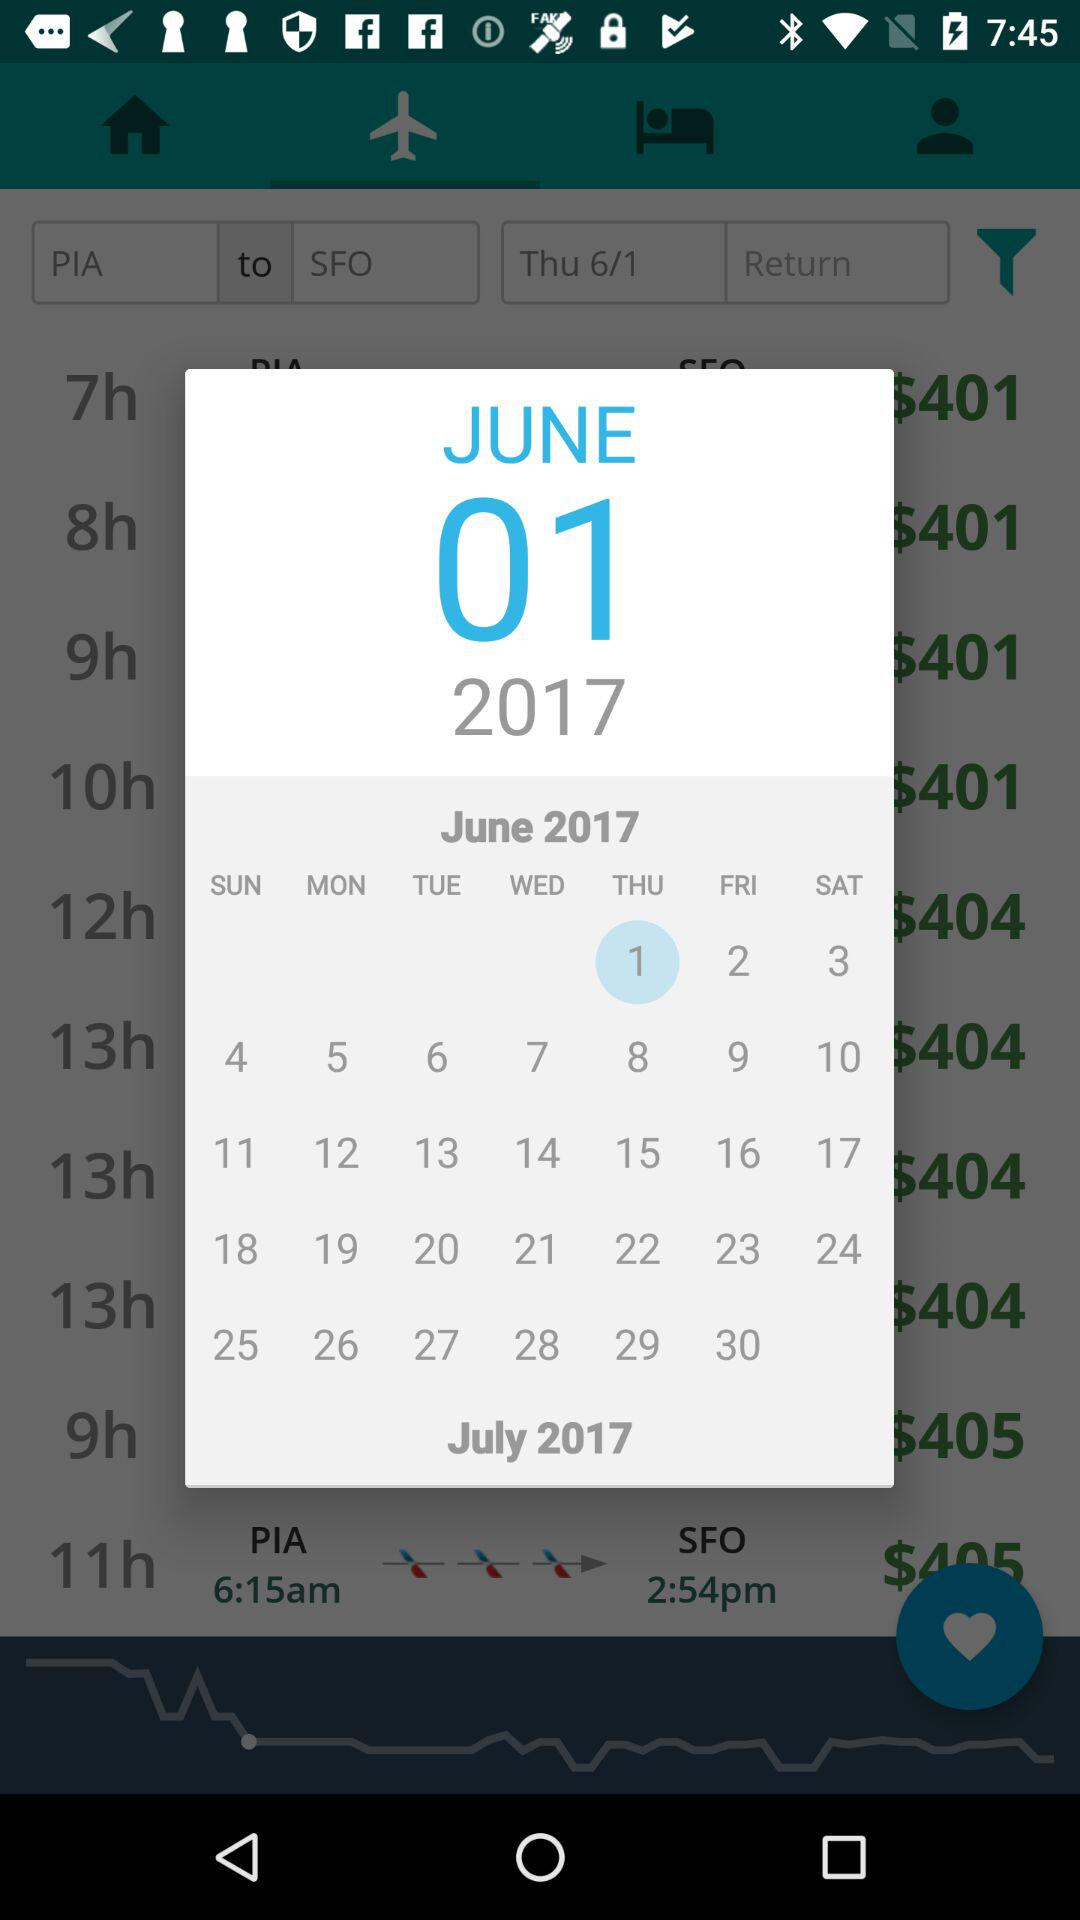What is the ticket price of a flight that takes 9 hours to reach SFO? The ticket prices of a flight that takes 9 hours to reach SFO are $401 and $405. 